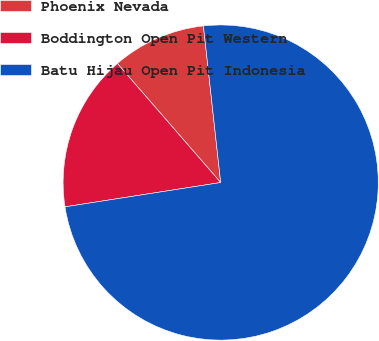Convert chart. <chart><loc_0><loc_0><loc_500><loc_500><pie_chart><fcel>Phoenix Nevada<fcel>Boddington Open Pit Western<fcel>Batu Hijau Open Pit Indonesia<nl><fcel>9.63%<fcel>16.09%<fcel>74.28%<nl></chart> 